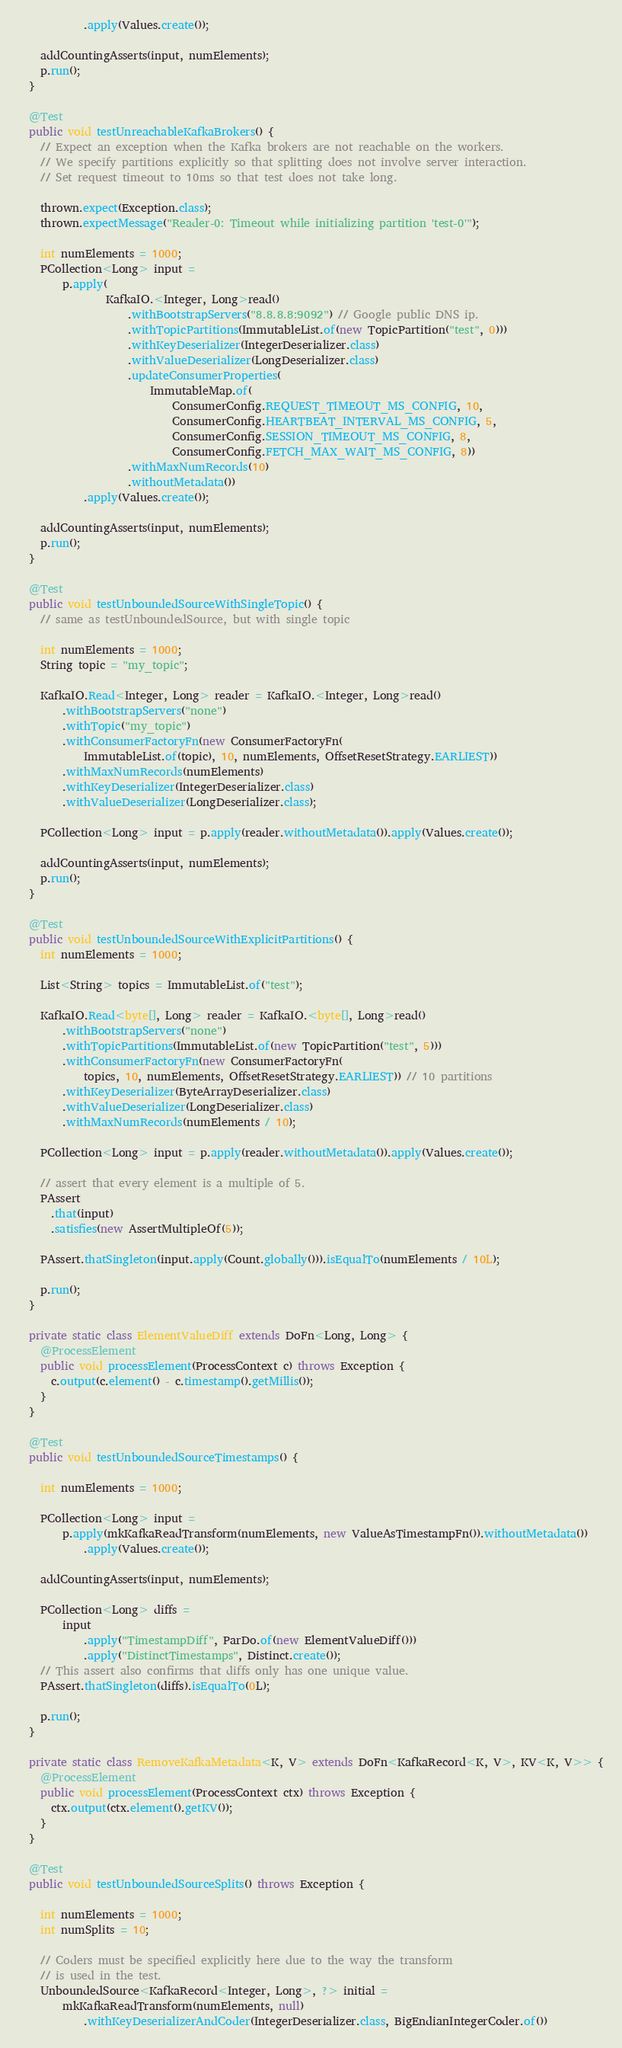Convert code to text. <code><loc_0><loc_0><loc_500><loc_500><_Java_>            .apply(Values.create());

    addCountingAsserts(input, numElements);
    p.run();
  }

  @Test
  public void testUnreachableKafkaBrokers() {
    // Expect an exception when the Kafka brokers are not reachable on the workers.
    // We specify partitions explicitly so that splitting does not involve server interaction.
    // Set request timeout to 10ms so that test does not take long.

    thrown.expect(Exception.class);
    thrown.expectMessage("Reader-0: Timeout while initializing partition 'test-0'");

    int numElements = 1000;
    PCollection<Long> input =
        p.apply(
                KafkaIO.<Integer, Long>read()
                    .withBootstrapServers("8.8.8.8:9092") // Google public DNS ip.
                    .withTopicPartitions(ImmutableList.of(new TopicPartition("test", 0)))
                    .withKeyDeserializer(IntegerDeserializer.class)
                    .withValueDeserializer(LongDeserializer.class)
                    .updateConsumerProperties(
                        ImmutableMap.of(
                            ConsumerConfig.REQUEST_TIMEOUT_MS_CONFIG, 10,
                            ConsumerConfig.HEARTBEAT_INTERVAL_MS_CONFIG, 5,
                            ConsumerConfig.SESSION_TIMEOUT_MS_CONFIG, 8,
                            ConsumerConfig.FETCH_MAX_WAIT_MS_CONFIG, 8))
                    .withMaxNumRecords(10)
                    .withoutMetadata())
            .apply(Values.create());

    addCountingAsserts(input, numElements);
    p.run();
  }

  @Test
  public void testUnboundedSourceWithSingleTopic() {
    // same as testUnboundedSource, but with single topic

    int numElements = 1000;
    String topic = "my_topic";

    KafkaIO.Read<Integer, Long> reader = KafkaIO.<Integer, Long>read()
        .withBootstrapServers("none")
        .withTopic("my_topic")
        .withConsumerFactoryFn(new ConsumerFactoryFn(
            ImmutableList.of(topic), 10, numElements, OffsetResetStrategy.EARLIEST))
        .withMaxNumRecords(numElements)
        .withKeyDeserializer(IntegerDeserializer.class)
        .withValueDeserializer(LongDeserializer.class);

    PCollection<Long> input = p.apply(reader.withoutMetadata()).apply(Values.create());

    addCountingAsserts(input, numElements);
    p.run();
  }

  @Test
  public void testUnboundedSourceWithExplicitPartitions() {
    int numElements = 1000;

    List<String> topics = ImmutableList.of("test");

    KafkaIO.Read<byte[], Long> reader = KafkaIO.<byte[], Long>read()
        .withBootstrapServers("none")
        .withTopicPartitions(ImmutableList.of(new TopicPartition("test", 5)))
        .withConsumerFactoryFn(new ConsumerFactoryFn(
            topics, 10, numElements, OffsetResetStrategy.EARLIEST)) // 10 partitions
        .withKeyDeserializer(ByteArrayDeserializer.class)
        .withValueDeserializer(LongDeserializer.class)
        .withMaxNumRecords(numElements / 10);

    PCollection<Long> input = p.apply(reader.withoutMetadata()).apply(Values.create());

    // assert that every element is a multiple of 5.
    PAssert
      .that(input)
      .satisfies(new AssertMultipleOf(5));

    PAssert.thatSingleton(input.apply(Count.globally())).isEqualTo(numElements / 10L);

    p.run();
  }

  private static class ElementValueDiff extends DoFn<Long, Long> {
    @ProcessElement
    public void processElement(ProcessContext c) throws Exception {
      c.output(c.element() - c.timestamp().getMillis());
    }
  }

  @Test
  public void testUnboundedSourceTimestamps() {

    int numElements = 1000;

    PCollection<Long> input =
        p.apply(mkKafkaReadTransform(numElements, new ValueAsTimestampFn()).withoutMetadata())
            .apply(Values.create());

    addCountingAsserts(input, numElements);

    PCollection<Long> diffs =
        input
            .apply("TimestampDiff", ParDo.of(new ElementValueDiff()))
            .apply("DistinctTimestamps", Distinct.create());
    // This assert also confirms that diffs only has one unique value.
    PAssert.thatSingleton(diffs).isEqualTo(0L);

    p.run();
  }

  private static class RemoveKafkaMetadata<K, V> extends DoFn<KafkaRecord<K, V>, KV<K, V>> {
    @ProcessElement
    public void processElement(ProcessContext ctx) throws Exception {
      ctx.output(ctx.element().getKV());
    }
  }

  @Test
  public void testUnboundedSourceSplits() throws Exception {

    int numElements = 1000;
    int numSplits = 10;

    // Coders must be specified explicitly here due to the way the transform
    // is used in the test.
    UnboundedSource<KafkaRecord<Integer, Long>, ?> initial =
        mkKafkaReadTransform(numElements, null)
            .withKeyDeserializerAndCoder(IntegerDeserializer.class, BigEndianIntegerCoder.of())</code> 